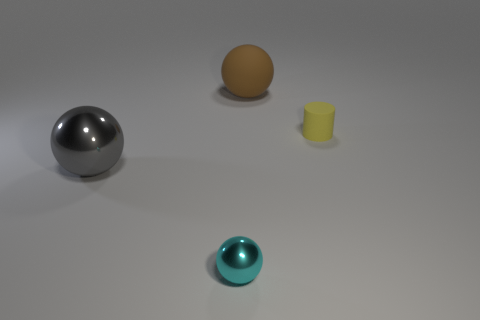Is the number of small yellow matte cylinders behind the yellow matte thing less than the number of big brown objects?
Offer a very short reply. Yes. There is a big ball that is in front of the tiny yellow rubber thing; what color is it?
Make the answer very short. Gray. There is a big thing that is on the right side of the large ball that is left of the brown sphere; what is its material?
Keep it short and to the point. Rubber. Is there a object that has the same size as the matte cylinder?
Offer a terse response. Yes. How many objects are either matte objects that are in front of the big matte thing or objects that are on the left side of the yellow rubber thing?
Offer a terse response. 4. Do the shiny sphere in front of the large gray sphere and the object behind the small matte cylinder have the same size?
Ensure brevity in your answer.  No. Is there a cyan metallic thing to the right of the metal sphere that is right of the big gray object?
Keep it short and to the point. No. What number of rubber balls are in front of the yellow thing?
Ensure brevity in your answer.  0. Are there fewer gray metallic balls behind the large brown ball than small cyan metallic objects behind the small cyan shiny sphere?
Offer a terse response. No. What number of things are big things that are in front of the large brown ball or big green matte cubes?
Offer a terse response. 1. 